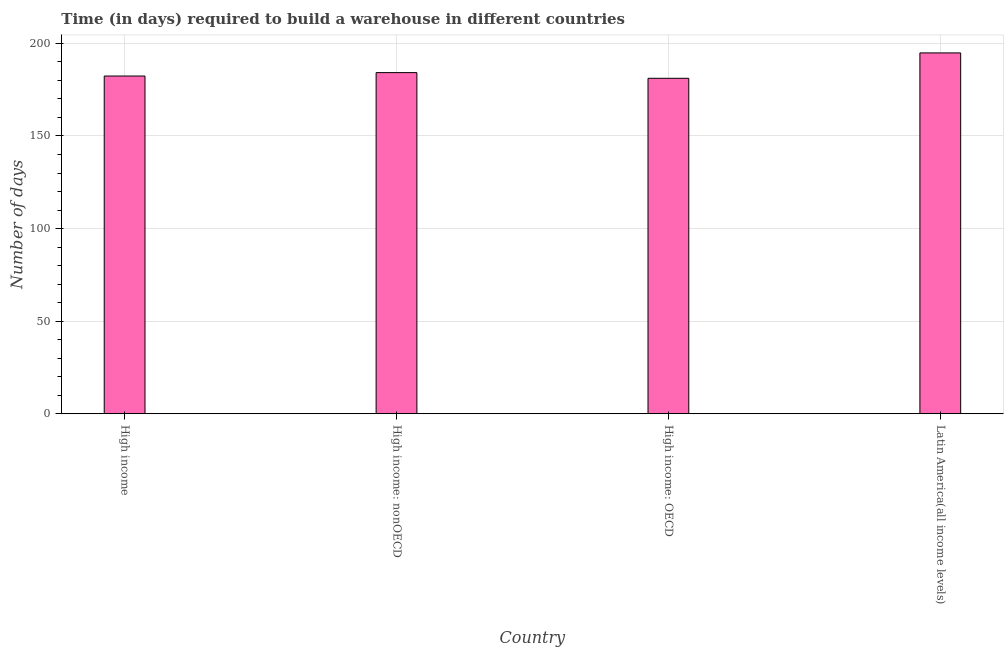Does the graph contain any zero values?
Offer a very short reply. No. Does the graph contain grids?
Your answer should be very brief. Yes. What is the title of the graph?
Provide a short and direct response. Time (in days) required to build a warehouse in different countries. What is the label or title of the Y-axis?
Give a very brief answer. Number of days. What is the time required to build a warehouse in High income?
Offer a very short reply. 182.38. Across all countries, what is the maximum time required to build a warehouse?
Provide a short and direct response. 194.86. Across all countries, what is the minimum time required to build a warehouse?
Make the answer very short. 181.15. In which country was the time required to build a warehouse maximum?
Provide a short and direct response. Latin America(all income levels). In which country was the time required to build a warehouse minimum?
Ensure brevity in your answer.  High income: OECD. What is the sum of the time required to build a warehouse?
Offer a very short reply. 742.62. What is the difference between the time required to build a warehouse in High income: nonOECD and Latin America(all income levels)?
Provide a succinct answer. -10.64. What is the average time required to build a warehouse per country?
Your answer should be compact. 185.65. What is the median time required to build a warehouse?
Ensure brevity in your answer.  183.3. What is the ratio of the time required to build a warehouse in High income: OECD to that in Latin America(all income levels)?
Keep it short and to the point. 0.93. What is the difference between the highest and the second highest time required to build a warehouse?
Provide a succinct answer. 10.64. Is the sum of the time required to build a warehouse in High income and High income: OECD greater than the maximum time required to build a warehouse across all countries?
Offer a terse response. Yes. What is the difference between the highest and the lowest time required to build a warehouse?
Offer a very short reply. 13.71. Are all the bars in the graph horizontal?
Offer a terse response. No. What is the Number of days of High income?
Provide a short and direct response. 182.38. What is the Number of days of High income: nonOECD?
Your response must be concise. 184.22. What is the Number of days of High income: OECD?
Your response must be concise. 181.15. What is the Number of days in Latin America(all income levels)?
Provide a succinct answer. 194.86. What is the difference between the Number of days in High income and High income: nonOECD?
Your answer should be very brief. -1.84. What is the difference between the Number of days in High income and High income: OECD?
Ensure brevity in your answer.  1.23. What is the difference between the Number of days in High income and Latin America(all income levels)?
Your answer should be very brief. -12.48. What is the difference between the Number of days in High income: nonOECD and High income: OECD?
Offer a very short reply. 3.08. What is the difference between the Number of days in High income: nonOECD and Latin America(all income levels)?
Offer a very short reply. -10.64. What is the difference between the Number of days in High income: OECD and Latin America(all income levels)?
Provide a short and direct response. -13.71. What is the ratio of the Number of days in High income to that in High income: nonOECD?
Make the answer very short. 0.99. What is the ratio of the Number of days in High income to that in Latin America(all income levels)?
Offer a terse response. 0.94. What is the ratio of the Number of days in High income: nonOECD to that in Latin America(all income levels)?
Your answer should be very brief. 0.94. 